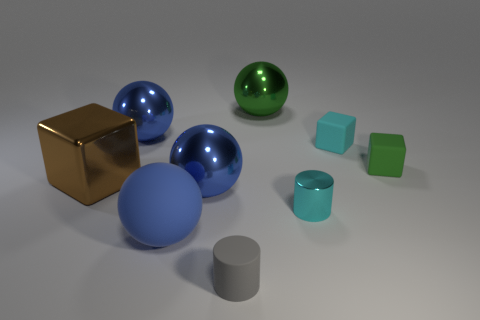What is the arrangement of objects, and does it suggest any particular pattern or purpose? The objects in the image are arranged in a seemingly random fashion across a flat surface. There is no evident pattern or intentional design to their placement that suggests a specific purpose. The various shapes and colors create a visually interesting assortment that may serve an aesthetic goal or be part of a conceptual art piece or a visual study of geometry and color. 